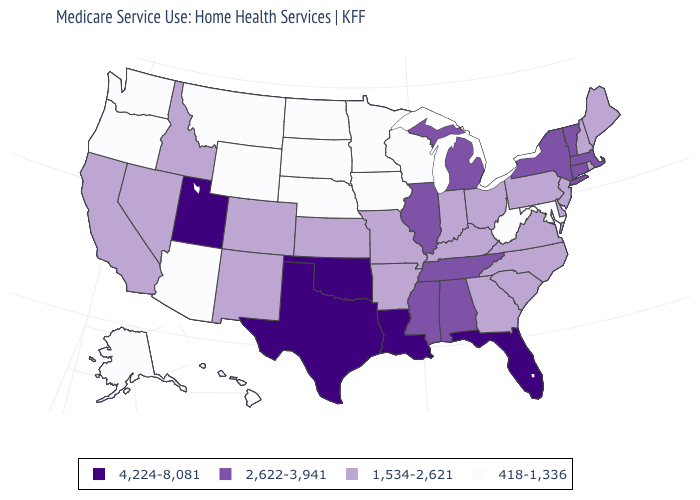What is the value of Idaho?
Quick response, please. 1,534-2,621. What is the value of New Mexico?
Be succinct. 1,534-2,621. Is the legend a continuous bar?
Keep it brief. No. Which states have the highest value in the USA?
Answer briefly. Florida, Louisiana, Oklahoma, Texas, Utah. Does Mississippi have the lowest value in the USA?
Answer briefly. No. What is the value of South Dakota?
Quick response, please. 418-1,336. Does Nebraska have the lowest value in the USA?
Quick response, please. Yes. What is the value of North Carolina?
Answer briefly. 1,534-2,621. What is the value of Nevada?
Quick response, please. 1,534-2,621. Name the states that have a value in the range 4,224-8,081?
Be succinct. Florida, Louisiana, Oklahoma, Texas, Utah. Name the states that have a value in the range 1,534-2,621?
Be succinct. Arkansas, California, Colorado, Delaware, Georgia, Idaho, Indiana, Kansas, Kentucky, Maine, Missouri, Nevada, New Hampshire, New Jersey, New Mexico, North Carolina, Ohio, Pennsylvania, Rhode Island, South Carolina, Virginia. Does the first symbol in the legend represent the smallest category?
Keep it brief. No. Which states have the highest value in the USA?
Give a very brief answer. Florida, Louisiana, Oklahoma, Texas, Utah. What is the value of Iowa?
Answer briefly. 418-1,336. Name the states that have a value in the range 418-1,336?
Give a very brief answer. Alaska, Arizona, Hawaii, Iowa, Maryland, Minnesota, Montana, Nebraska, North Dakota, Oregon, South Dakota, Washington, West Virginia, Wisconsin, Wyoming. 